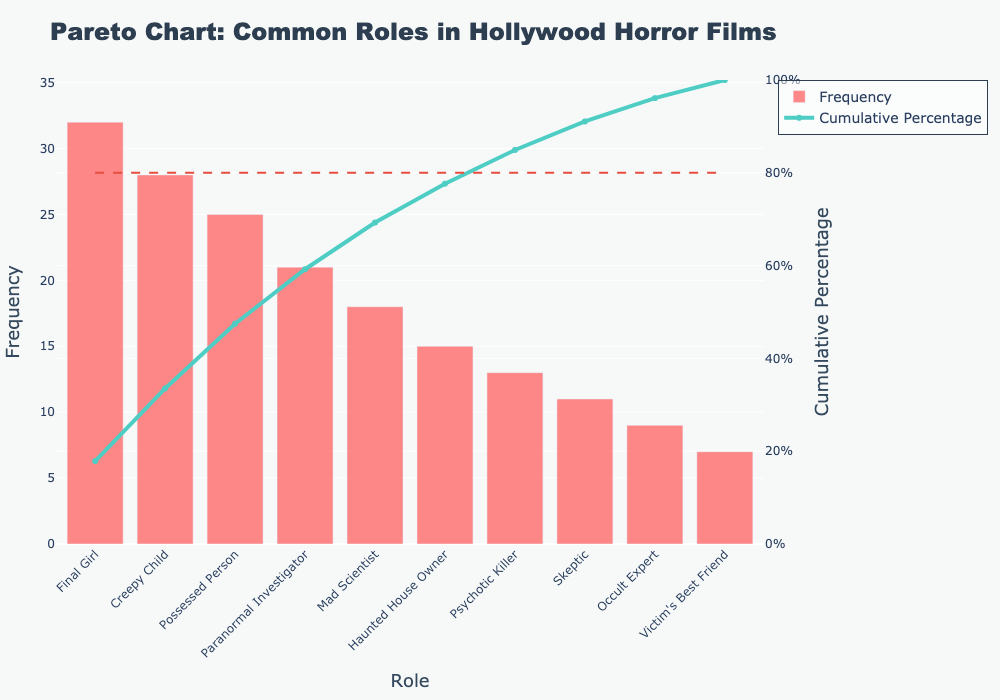What is the most common role in Hollywood horror films according to the chart? The highest bar represents the most common role, which is 'Final Girl' with the highest frequency.
Answer: Final Girl What is the cumulative percentage of the 'Possessed Person' role? The cumulative percentage for 'Possessed Person' can be read directly from the line chart at the 'Possessed Person' point.
Answer: 65% How much more frequent is the 'Final Girl' role compared to the 'Psychotic Killer' role? 'Final Girl' has a frequency of 32 and 'Psychotic Killer' has a frequency of 13. The difference is 32 - 13.
Answer: 19 What roles make up approximately 80% of the total frequency in the chart? To determine this, check the cumulative percentage line in relation to the horizontal 80% line. The roles contributing up to this point are 'Final Girl', 'Creepy Child', 'Possessed Person', and 'Paranormal Investigator'.
Answer: Final Girl, Creepy Child, Possessed Person, Paranormal Investigator Which role has the lowest frequency, and what is its cumulative percentage? The lowest bar represents the least frequent role, which is 'Victim's Best Friend', and its cumulative percentage can be read off the line chart.
Answer: Victim's Best Friend; 100% What is the combined frequency of the 'Haunted House Owner' and 'Psychotic Killer' roles? Summing the frequencies of 'Haunted House Owner' (15) and 'Psychotic Killer' (13) gives us 15 + 13.
Answer: 28 If you wanted to aim for a role that is within the top 50% of frequencies, which roles could you consider? The cumulative percentages show which roles make up the first 50%. Roles up to approximately 50% are 'Final Girl', 'Creepy Child', and 'Possessed Person'.
Answer: Final Girl, Creepy Child, Possessed Person What is the difference in cumulative percentages between 'Paranormal Investigator' and 'Occult Expert'? Cumulative percentage of 'Paranormal Investigator' is 75%, and for 'Occult Expert' it is 96%. The difference is 96% - 75%.
Answer: 21% 